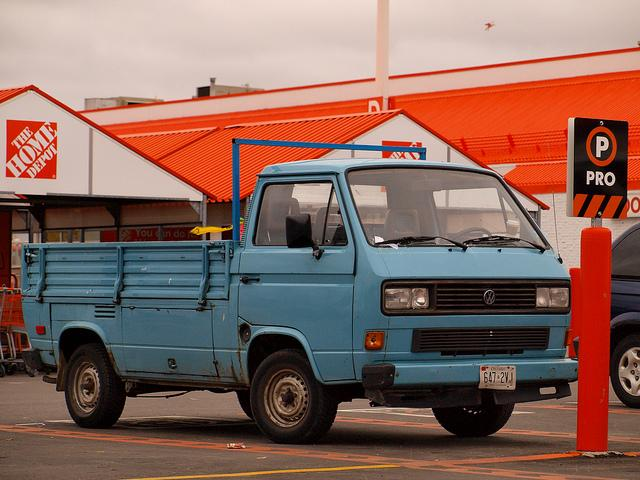What does the store to the left sell? Please explain your reasoning. hammers. The store sells hammers. 